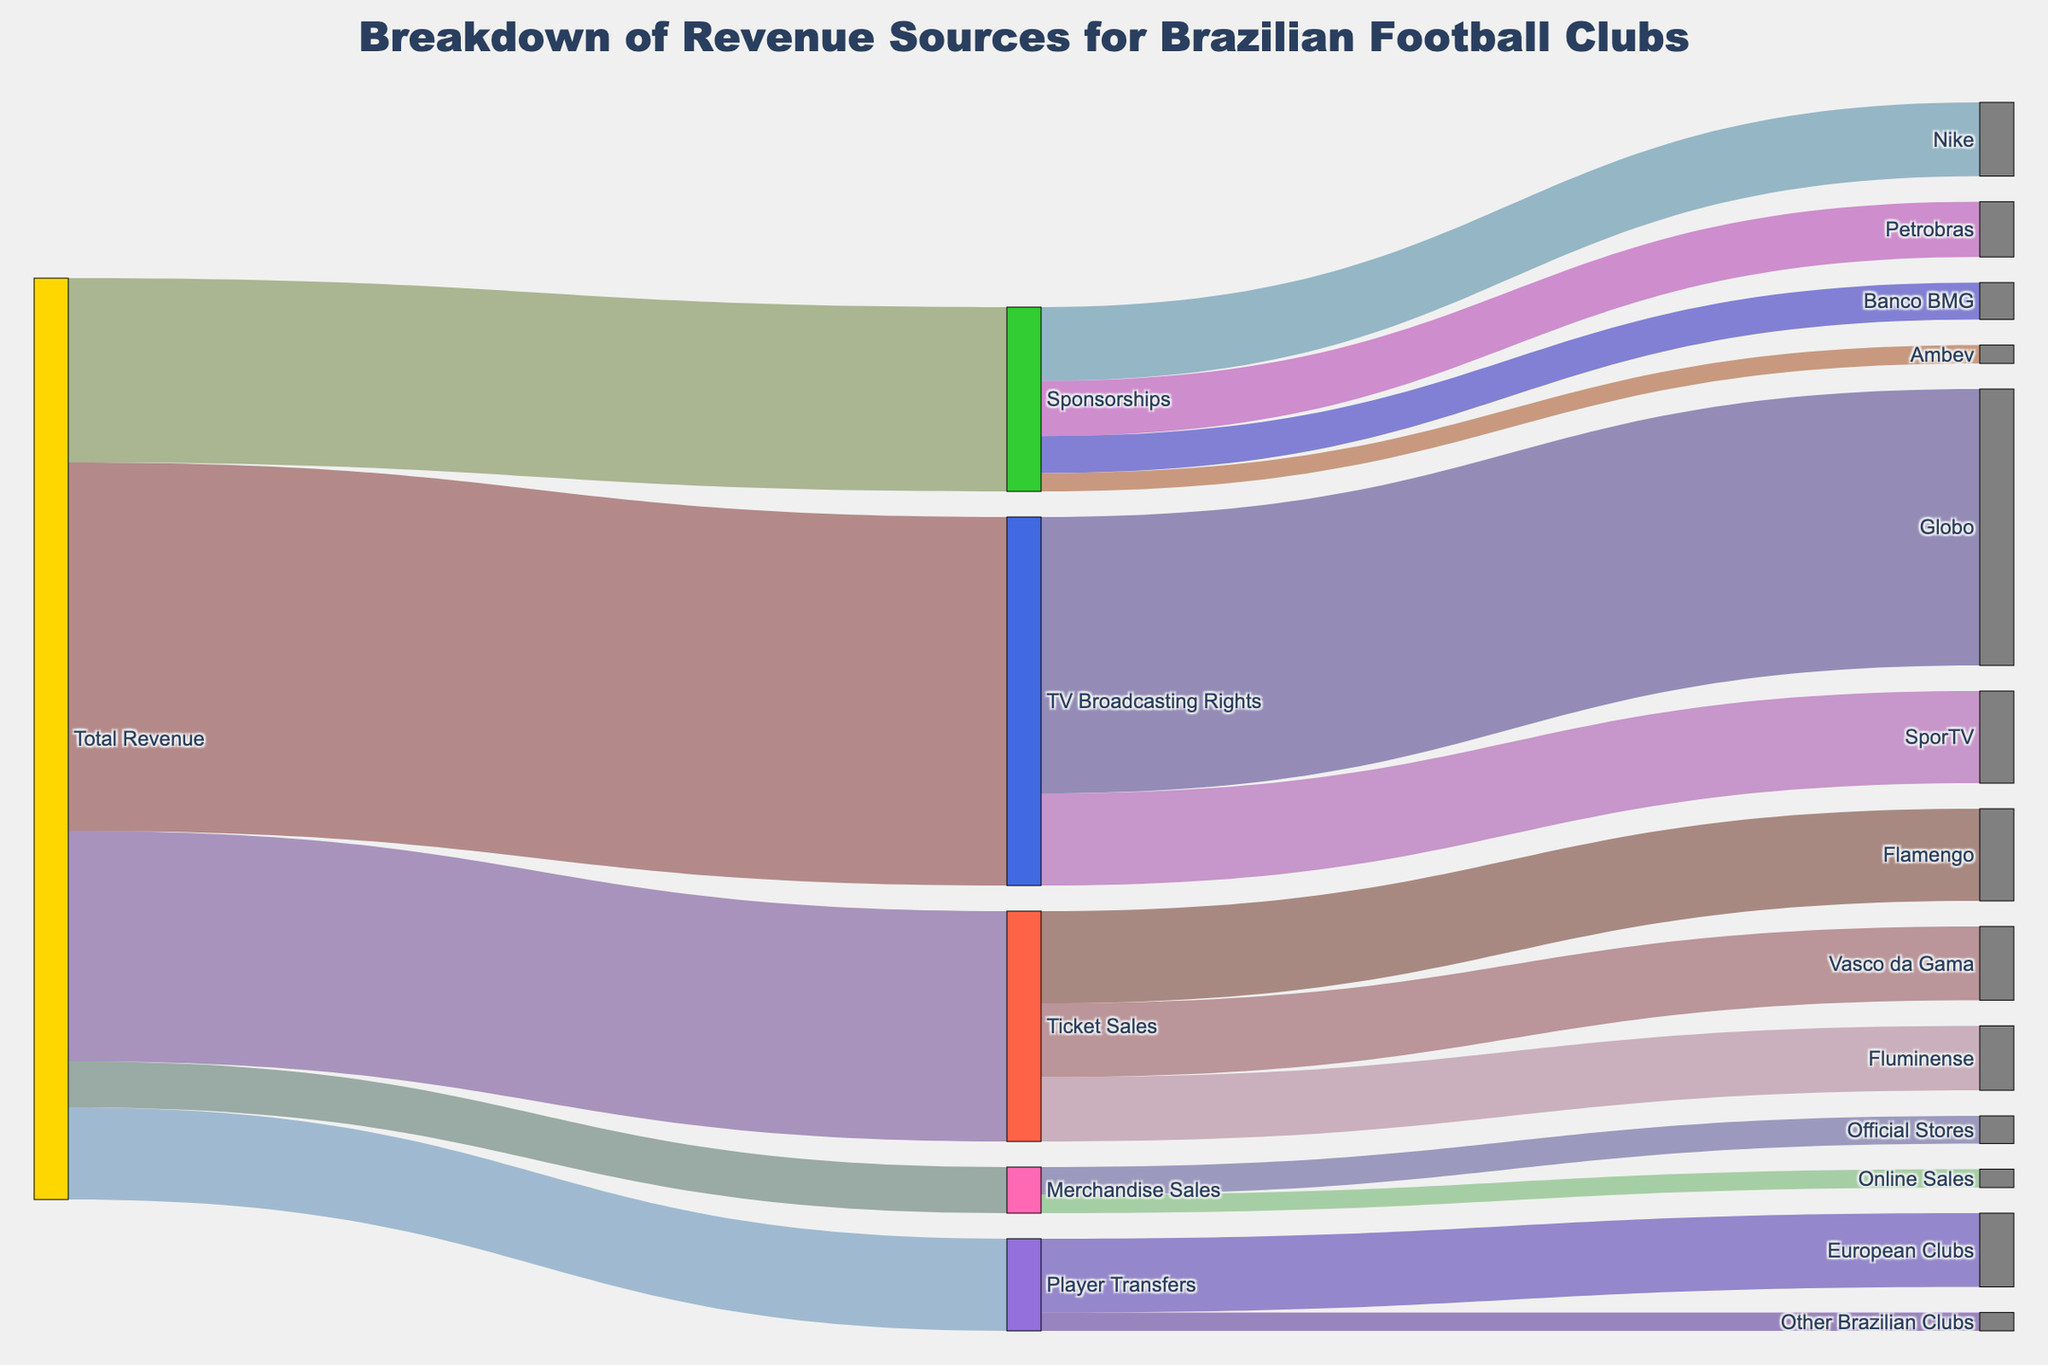Which revenue source contributes the most to the total revenue? The largest segment originating from the "Total Revenue" node has the greatest contribution. "TV Broadcasting Rights" has the highest flow value of 40.
Answer: TV Broadcasting Rights Which football club has the highest revenue from ticket sales? The figures connected from "Ticket Sales" show the values distributed among clubs. Flamengo has the highest value connected to "Ticket Sales" with 10.
Answer: Flamengo What is the total revenue generated from sponsorships? Adding all the values connected to "Sponsorships" from their respective sources gives the total. Values are 8 (Nike), 6 (Petrobras), 4 (Banco BMG), and 2 (Ambev), so 8 + 6 + 4 + 2 = 20.
Answer: 20 How much revenue comes from player transfers to European Clubs? From the "Player Transfers" node, check the value connected to "European Clubs". The value is 8.
Answer: 8 Are merchandise sales from official stores higher than from online sales? Compare the flow values from "Merchandise Sales" to "Official Stores" and "Online Sales". Official Stores has 3, whereas Online Sales has 2.
Answer: Yes What is the smallest revenue source for the total revenue? The smallest segment connected from "Total Revenue" has the least contribution. "Merchandise Sales" has a value of 5, which is the least.
Answer: Merchandise Sales What percentage of the total revenue does TV Broadcasting Rights contribute? Sum all values originating from "Total Revenue" to get the total revenue: 25 (Ticket Sales) + 40 (TV Broadcasting Rights) + 20 (Sponsorships) + 10 (Player Transfers) + 5 (Merchandise Sales) = 100. The percentage for TV Broadcasting Rights is (40 / 100) * 100%.
Answer: 40% How does the revenue from Globo compare to that from SporTV? Both are directly connected to "TV Broadcasting Rights". Globo has 30 and SporTV has 10. Globo's revenue is higher.
Answer: Globo has higher revenue Which sponsor contributes the least to the Sponsorships revenue? The smallest value segment connected from "Sponsorships" shows the least contribution. Ambev has a value of 2, the least among sponsors.
Answer: Ambev 